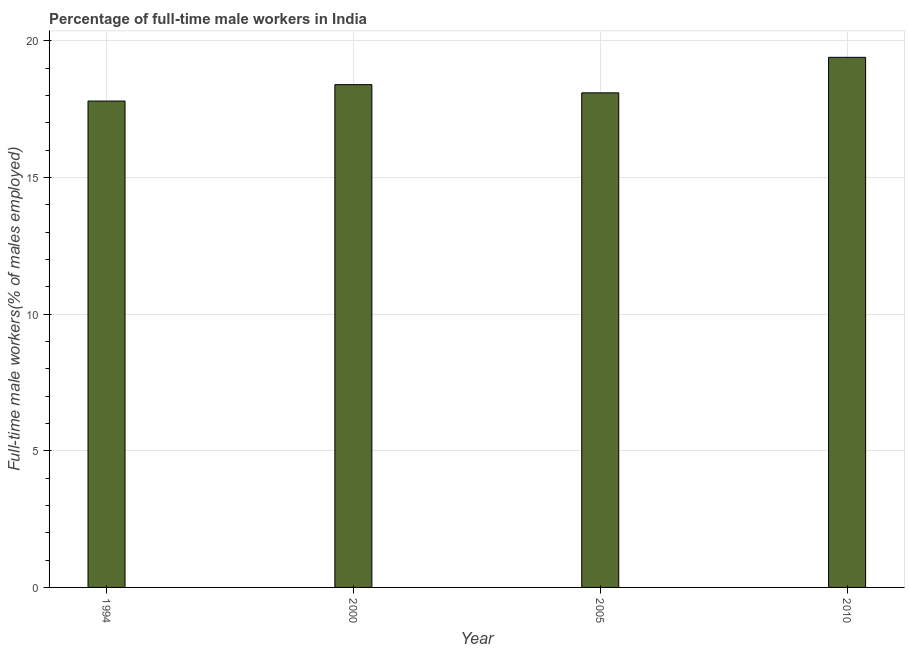What is the title of the graph?
Your response must be concise. Percentage of full-time male workers in India. What is the label or title of the Y-axis?
Make the answer very short. Full-time male workers(% of males employed). What is the percentage of full-time male workers in 2000?
Ensure brevity in your answer.  18.4. Across all years, what is the maximum percentage of full-time male workers?
Your answer should be compact. 19.4. Across all years, what is the minimum percentage of full-time male workers?
Keep it short and to the point. 17.8. In which year was the percentage of full-time male workers maximum?
Your answer should be compact. 2010. What is the sum of the percentage of full-time male workers?
Provide a short and direct response. 73.7. What is the difference between the percentage of full-time male workers in 2005 and 2010?
Offer a very short reply. -1.3. What is the average percentage of full-time male workers per year?
Give a very brief answer. 18.43. What is the median percentage of full-time male workers?
Offer a very short reply. 18.25. In how many years, is the percentage of full-time male workers greater than 19 %?
Offer a terse response. 1. Do a majority of the years between 2000 and 2005 (inclusive) have percentage of full-time male workers greater than 12 %?
Keep it short and to the point. Yes. What is the ratio of the percentage of full-time male workers in 1994 to that in 2000?
Your response must be concise. 0.97. Is the difference between the percentage of full-time male workers in 1994 and 2005 greater than the difference between any two years?
Your answer should be very brief. No. What is the difference between the highest and the second highest percentage of full-time male workers?
Offer a terse response. 1. Is the sum of the percentage of full-time male workers in 2005 and 2010 greater than the maximum percentage of full-time male workers across all years?
Offer a very short reply. Yes. Are the values on the major ticks of Y-axis written in scientific E-notation?
Your answer should be very brief. No. What is the Full-time male workers(% of males employed) of 1994?
Make the answer very short. 17.8. What is the Full-time male workers(% of males employed) in 2000?
Offer a terse response. 18.4. What is the Full-time male workers(% of males employed) in 2005?
Your answer should be compact. 18.1. What is the Full-time male workers(% of males employed) of 2010?
Offer a terse response. 19.4. What is the difference between the Full-time male workers(% of males employed) in 1994 and 2000?
Ensure brevity in your answer.  -0.6. What is the difference between the Full-time male workers(% of males employed) in 1994 and 2005?
Give a very brief answer. -0.3. What is the difference between the Full-time male workers(% of males employed) in 2000 and 2010?
Give a very brief answer. -1. What is the difference between the Full-time male workers(% of males employed) in 2005 and 2010?
Provide a short and direct response. -1.3. What is the ratio of the Full-time male workers(% of males employed) in 1994 to that in 2000?
Offer a terse response. 0.97. What is the ratio of the Full-time male workers(% of males employed) in 1994 to that in 2010?
Ensure brevity in your answer.  0.92. What is the ratio of the Full-time male workers(% of males employed) in 2000 to that in 2005?
Your response must be concise. 1.02. What is the ratio of the Full-time male workers(% of males employed) in 2000 to that in 2010?
Give a very brief answer. 0.95. What is the ratio of the Full-time male workers(% of males employed) in 2005 to that in 2010?
Ensure brevity in your answer.  0.93. 